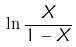Convert formula to latex. <formula><loc_0><loc_0><loc_500><loc_500>\ln { \frac { X } { 1 - X } }</formula> 